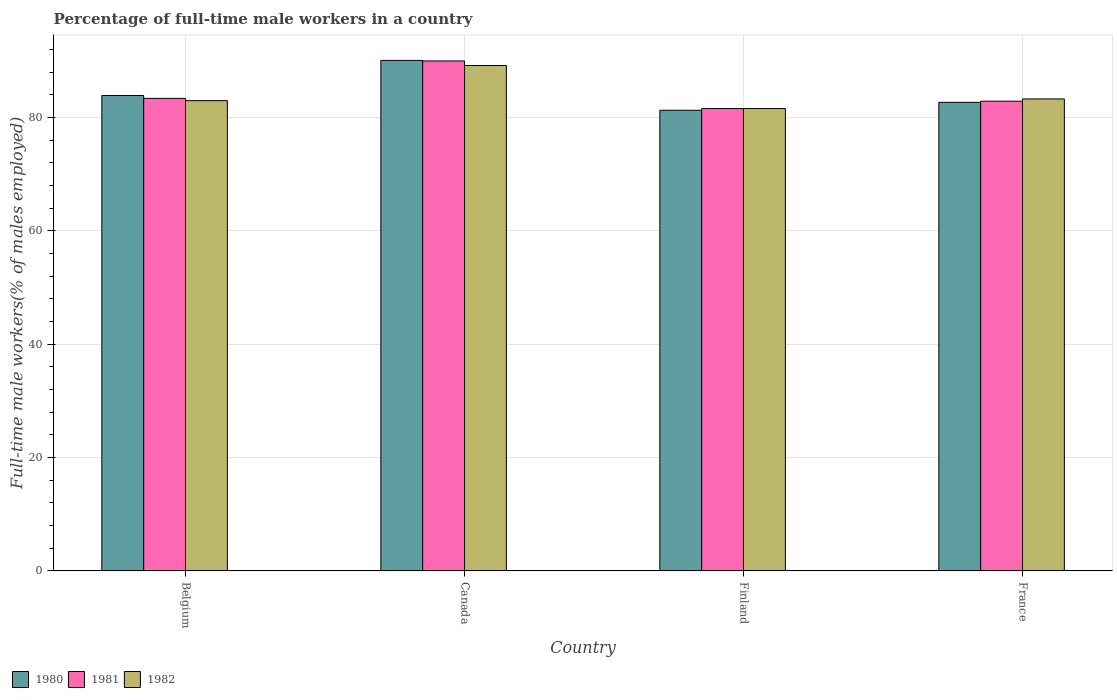How many different coloured bars are there?
Keep it short and to the point. 3. How many groups of bars are there?
Provide a succinct answer. 4. Are the number of bars per tick equal to the number of legend labels?
Your answer should be compact. Yes. Are the number of bars on each tick of the X-axis equal?
Your answer should be compact. Yes. What is the label of the 3rd group of bars from the left?
Keep it short and to the point. Finland. In how many cases, is the number of bars for a given country not equal to the number of legend labels?
Provide a succinct answer. 0. What is the percentage of full-time male workers in 1980 in Belgium?
Your answer should be very brief. 83.9. Across all countries, what is the maximum percentage of full-time male workers in 1980?
Give a very brief answer. 90.1. Across all countries, what is the minimum percentage of full-time male workers in 1982?
Your answer should be compact. 81.6. In which country was the percentage of full-time male workers in 1981 maximum?
Your answer should be very brief. Canada. What is the total percentage of full-time male workers in 1981 in the graph?
Give a very brief answer. 337.9. What is the difference between the percentage of full-time male workers in 1980 in Canada and that in Finland?
Keep it short and to the point. 8.8. What is the difference between the percentage of full-time male workers in 1981 in Canada and the percentage of full-time male workers in 1980 in Finland?
Your response must be concise. 8.7. What is the average percentage of full-time male workers in 1981 per country?
Your answer should be very brief. 84.48. What is the difference between the percentage of full-time male workers of/in 1982 and percentage of full-time male workers of/in 1980 in Belgium?
Provide a succinct answer. -0.9. In how many countries, is the percentage of full-time male workers in 1982 greater than 60 %?
Offer a very short reply. 4. What is the ratio of the percentage of full-time male workers in 1980 in Finland to that in France?
Ensure brevity in your answer.  0.98. Is the percentage of full-time male workers in 1981 in Belgium less than that in Finland?
Make the answer very short. No. What is the difference between the highest and the second highest percentage of full-time male workers in 1981?
Your answer should be very brief. 6.6. What is the difference between the highest and the lowest percentage of full-time male workers in 1982?
Your response must be concise. 7.6. In how many countries, is the percentage of full-time male workers in 1981 greater than the average percentage of full-time male workers in 1981 taken over all countries?
Provide a succinct answer. 1. What does the 3rd bar from the left in France represents?
Provide a succinct answer. 1982. What does the 2nd bar from the right in Canada represents?
Give a very brief answer. 1981. How many countries are there in the graph?
Ensure brevity in your answer.  4. Are the values on the major ticks of Y-axis written in scientific E-notation?
Ensure brevity in your answer.  No. Does the graph contain any zero values?
Keep it short and to the point. No. Does the graph contain grids?
Your response must be concise. Yes. Where does the legend appear in the graph?
Give a very brief answer. Bottom left. What is the title of the graph?
Your response must be concise. Percentage of full-time male workers in a country. What is the label or title of the X-axis?
Provide a short and direct response. Country. What is the label or title of the Y-axis?
Provide a short and direct response. Full-time male workers(% of males employed). What is the Full-time male workers(% of males employed) of 1980 in Belgium?
Ensure brevity in your answer.  83.9. What is the Full-time male workers(% of males employed) of 1981 in Belgium?
Your answer should be compact. 83.4. What is the Full-time male workers(% of males employed) in 1982 in Belgium?
Your answer should be very brief. 83. What is the Full-time male workers(% of males employed) of 1980 in Canada?
Keep it short and to the point. 90.1. What is the Full-time male workers(% of males employed) of 1981 in Canada?
Your response must be concise. 90. What is the Full-time male workers(% of males employed) in 1982 in Canada?
Your answer should be compact. 89.2. What is the Full-time male workers(% of males employed) in 1980 in Finland?
Provide a short and direct response. 81.3. What is the Full-time male workers(% of males employed) of 1981 in Finland?
Offer a terse response. 81.6. What is the Full-time male workers(% of males employed) of 1982 in Finland?
Your response must be concise. 81.6. What is the Full-time male workers(% of males employed) of 1980 in France?
Your answer should be compact. 82.7. What is the Full-time male workers(% of males employed) in 1981 in France?
Your response must be concise. 82.9. What is the Full-time male workers(% of males employed) in 1982 in France?
Your answer should be very brief. 83.3. Across all countries, what is the maximum Full-time male workers(% of males employed) in 1980?
Your answer should be compact. 90.1. Across all countries, what is the maximum Full-time male workers(% of males employed) in 1981?
Give a very brief answer. 90. Across all countries, what is the maximum Full-time male workers(% of males employed) in 1982?
Provide a short and direct response. 89.2. Across all countries, what is the minimum Full-time male workers(% of males employed) in 1980?
Your answer should be very brief. 81.3. Across all countries, what is the minimum Full-time male workers(% of males employed) in 1981?
Provide a short and direct response. 81.6. Across all countries, what is the minimum Full-time male workers(% of males employed) in 1982?
Offer a very short reply. 81.6. What is the total Full-time male workers(% of males employed) of 1980 in the graph?
Make the answer very short. 338. What is the total Full-time male workers(% of males employed) in 1981 in the graph?
Ensure brevity in your answer.  337.9. What is the total Full-time male workers(% of males employed) in 1982 in the graph?
Your answer should be compact. 337.1. What is the difference between the Full-time male workers(% of males employed) in 1980 in Belgium and that in Canada?
Make the answer very short. -6.2. What is the difference between the Full-time male workers(% of males employed) of 1981 in Belgium and that in Finland?
Give a very brief answer. 1.8. What is the difference between the Full-time male workers(% of males employed) in 1982 in Belgium and that in France?
Make the answer very short. -0.3. What is the difference between the Full-time male workers(% of males employed) in 1980 in Canada and that in Finland?
Your answer should be compact. 8.8. What is the difference between the Full-time male workers(% of males employed) of 1981 in Canada and that in Finland?
Provide a succinct answer. 8.4. What is the difference between the Full-time male workers(% of males employed) in 1982 in Canada and that in Finland?
Make the answer very short. 7.6. What is the difference between the Full-time male workers(% of males employed) in 1980 in Finland and that in France?
Your response must be concise. -1.4. What is the difference between the Full-time male workers(% of males employed) of 1982 in Finland and that in France?
Provide a succinct answer. -1.7. What is the difference between the Full-time male workers(% of males employed) in 1980 in Belgium and the Full-time male workers(% of males employed) in 1982 in Canada?
Provide a short and direct response. -5.3. What is the difference between the Full-time male workers(% of males employed) in 1980 in Belgium and the Full-time male workers(% of males employed) in 1981 in Finland?
Your answer should be compact. 2.3. What is the difference between the Full-time male workers(% of males employed) of 1981 in Belgium and the Full-time male workers(% of males employed) of 1982 in Finland?
Ensure brevity in your answer.  1.8. What is the difference between the Full-time male workers(% of males employed) in 1980 in Belgium and the Full-time male workers(% of males employed) in 1981 in France?
Your answer should be very brief. 1. What is the difference between the Full-time male workers(% of males employed) in 1981 in Belgium and the Full-time male workers(% of males employed) in 1982 in France?
Offer a terse response. 0.1. What is the difference between the Full-time male workers(% of males employed) of 1980 in Canada and the Full-time male workers(% of males employed) of 1982 in Finland?
Your answer should be compact. 8.5. What is the difference between the Full-time male workers(% of males employed) of 1980 in Canada and the Full-time male workers(% of males employed) of 1982 in France?
Your answer should be very brief. 6.8. What is the difference between the Full-time male workers(% of males employed) in 1981 in Canada and the Full-time male workers(% of males employed) in 1982 in France?
Your answer should be compact. 6.7. What is the difference between the Full-time male workers(% of males employed) of 1980 in Finland and the Full-time male workers(% of males employed) of 1981 in France?
Your response must be concise. -1.6. What is the difference between the Full-time male workers(% of males employed) in 1980 in Finland and the Full-time male workers(% of males employed) in 1982 in France?
Offer a very short reply. -2. What is the difference between the Full-time male workers(% of males employed) of 1981 in Finland and the Full-time male workers(% of males employed) of 1982 in France?
Your answer should be compact. -1.7. What is the average Full-time male workers(% of males employed) of 1980 per country?
Provide a succinct answer. 84.5. What is the average Full-time male workers(% of males employed) of 1981 per country?
Your answer should be compact. 84.47. What is the average Full-time male workers(% of males employed) of 1982 per country?
Offer a very short reply. 84.28. What is the difference between the Full-time male workers(% of males employed) of 1980 and Full-time male workers(% of males employed) of 1981 in Belgium?
Provide a short and direct response. 0.5. What is the difference between the Full-time male workers(% of males employed) in 1981 and Full-time male workers(% of males employed) in 1982 in Belgium?
Offer a very short reply. 0.4. What is the difference between the Full-time male workers(% of males employed) of 1980 and Full-time male workers(% of males employed) of 1981 in Canada?
Provide a succinct answer. 0.1. What is the difference between the Full-time male workers(% of males employed) in 1980 and Full-time male workers(% of males employed) in 1982 in Canada?
Keep it short and to the point. 0.9. What is the difference between the Full-time male workers(% of males employed) of 1980 and Full-time male workers(% of males employed) of 1981 in Finland?
Provide a succinct answer. -0.3. What is the difference between the Full-time male workers(% of males employed) of 1980 and Full-time male workers(% of males employed) of 1981 in France?
Keep it short and to the point. -0.2. What is the difference between the Full-time male workers(% of males employed) in 1980 and Full-time male workers(% of males employed) in 1982 in France?
Provide a short and direct response. -0.6. What is the difference between the Full-time male workers(% of males employed) in 1981 and Full-time male workers(% of males employed) in 1982 in France?
Your answer should be very brief. -0.4. What is the ratio of the Full-time male workers(% of males employed) of 1980 in Belgium to that in Canada?
Provide a short and direct response. 0.93. What is the ratio of the Full-time male workers(% of males employed) in 1981 in Belgium to that in Canada?
Your answer should be very brief. 0.93. What is the ratio of the Full-time male workers(% of males employed) of 1982 in Belgium to that in Canada?
Provide a short and direct response. 0.93. What is the ratio of the Full-time male workers(% of males employed) of 1980 in Belgium to that in Finland?
Offer a very short reply. 1.03. What is the ratio of the Full-time male workers(% of males employed) of 1981 in Belgium to that in Finland?
Provide a succinct answer. 1.02. What is the ratio of the Full-time male workers(% of males employed) of 1982 in Belgium to that in Finland?
Ensure brevity in your answer.  1.02. What is the ratio of the Full-time male workers(% of males employed) in 1980 in Belgium to that in France?
Give a very brief answer. 1.01. What is the ratio of the Full-time male workers(% of males employed) of 1982 in Belgium to that in France?
Offer a terse response. 1. What is the ratio of the Full-time male workers(% of males employed) of 1980 in Canada to that in Finland?
Offer a terse response. 1.11. What is the ratio of the Full-time male workers(% of males employed) of 1981 in Canada to that in Finland?
Make the answer very short. 1.1. What is the ratio of the Full-time male workers(% of males employed) in 1982 in Canada to that in Finland?
Your answer should be very brief. 1.09. What is the ratio of the Full-time male workers(% of males employed) of 1980 in Canada to that in France?
Give a very brief answer. 1.09. What is the ratio of the Full-time male workers(% of males employed) in 1981 in Canada to that in France?
Offer a terse response. 1.09. What is the ratio of the Full-time male workers(% of males employed) of 1982 in Canada to that in France?
Provide a short and direct response. 1.07. What is the ratio of the Full-time male workers(% of males employed) of 1980 in Finland to that in France?
Provide a short and direct response. 0.98. What is the ratio of the Full-time male workers(% of males employed) of 1981 in Finland to that in France?
Give a very brief answer. 0.98. What is the ratio of the Full-time male workers(% of males employed) of 1982 in Finland to that in France?
Your response must be concise. 0.98. What is the difference between the highest and the second highest Full-time male workers(% of males employed) in 1981?
Keep it short and to the point. 6.6. What is the difference between the highest and the second highest Full-time male workers(% of males employed) in 1982?
Make the answer very short. 5.9. What is the difference between the highest and the lowest Full-time male workers(% of males employed) of 1980?
Offer a terse response. 8.8. 